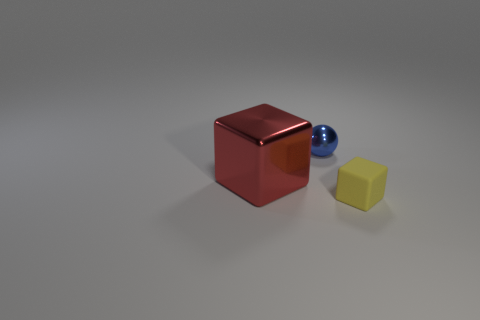Is there anything else that has the same size as the red shiny cube?
Your response must be concise. No. How many things are behind the yellow object and in front of the blue object?
Your answer should be very brief. 1. What is the color of the big shiny object?
Keep it short and to the point. Red. What material is the other big red object that is the same shape as the rubber object?
Offer a terse response. Metal. Is there anything else that is made of the same material as the tiny yellow object?
Offer a very short reply. No. What shape is the thing behind the block behind the matte thing?
Offer a very short reply. Sphere. What is the shape of the other object that is the same material as the blue object?
Your answer should be compact. Cube. How many other things are the same shape as the rubber thing?
Make the answer very short. 1. There is a cube to the left of the matte block; does it have the same size as the small blue shiny object?
Keep it short and to the point. No. Are there more things that are to the right of the red metal thing than green rubber spheres?
Offer a very short reply. Yes. 